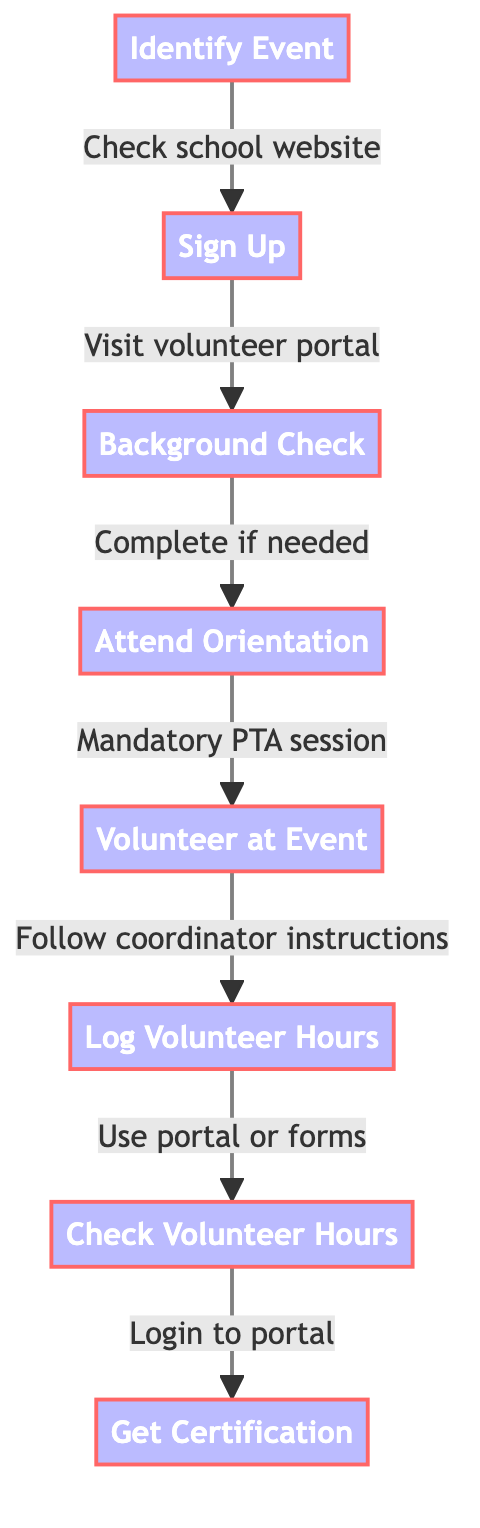What is the first step in the diagram? The first step, as indicated in the diagram, is "Identify Event". This is shown as the initial node in the flowchart leading to the next step.
Answer: Identify Event How many total steps are in this flowchart? By counting each unique step represented in the flowchart, there are a total of eight distinct steps listed.
Answer: Eight What is required before attending the orientation? The flowchart indicates that the prerequisite for attending orientation is completing the "Background Check". This step must be done prior to attending the orientation node.
Answer: Background Check What do you do after volunteering at an event? Following the volunteering step, the next action required is to "Log Volunteer Hours", as indicated by the flow from the volunteering node.
Answer: Log Volunteer Hours Which step comes directly after signing up? After the "Sign Up" step, the next step outlined in the flowchart is "Background Check", making it the immediate next action.
Answer: Background Check What is the last step listed in the flowchart? The last step indicated in the diagram is "Get Certification", which is the final node of the flowchart accessed after checking volunteer hours.
Answer: Get Certification What must you do to check your volunteer hours? To check your volunteer hours, you must "Login to portal", as specified in the corresponding step in the flowchart.
Answer: Login to portal How many steps are there between signing up and volunteering at the event? There are two steps between "Sign Up" and "Volunteer at Event": "Background Check" and "Attend Orientation". Thus, the total is two steps.
Answer: Two 